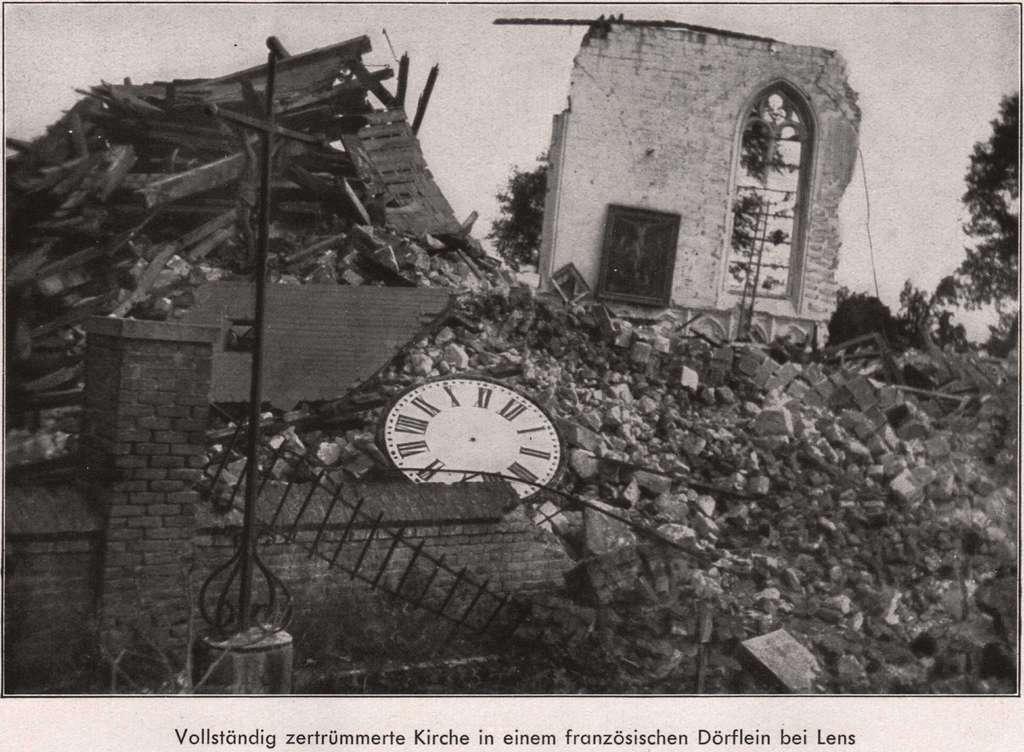What is the first word in the sentence?
Make the answer very short. Vollstandig. What is the last word written in the sentence?
Provide a short and direct response. Lens. 